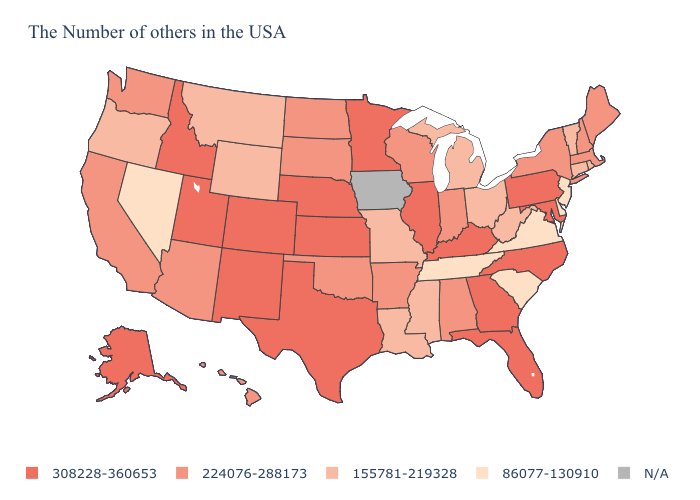Name the states that have a value in the range 308228-360653?
Write a very short answer. Maryland, Pennsylvania, North Carolina, Florida, Georgia, Kentucky, Illinois, Minnesota, Kansas, Nebraska, Texas, Colorado, New Mexico, Utah, Idaho, Alaska. What is the value of Wisconsin?
Write a very short answer. 224076-288173. Does the first symbol in the legend represent the smallest category?
Be succinct. No. What is the value of North Carolina?
Write a very short answer. 308228-360653. Does Arizona have the highest value in the USA?
Give a very brief answer. No. Which states have the lowest value in the USA?
Be succinct. New Jersey, Delaware, Virginia, South Carolina, Tennessee, Nevada. What is the highest value in states that border North Carolina?
Give a very brief answer. 308228-360653. Does Tennessee have the lowest value in the USA?
Concise answer only. Yes. Does Maryland have the lowest value in the USA?
Keep it brief. No. Name the states that have a value in the range 155781-219328?
Give a very brief answer. Rhode Island, Vermont, Connecticut, West Virginia, Ohio, Michigan, Mississippi, Louisiana, Missouri, Wyoming, Montana, Oregon. Does Washington have the highest value in the West?
Short answer required. No. Name the states that have a value in the range 86077-130910?
Quick response, please. New Jersey, Delaware, Virginia, South Carolina, Tennessee, Nevada. What is the value of Minnesota?
Be succinct. 308228-360653. 